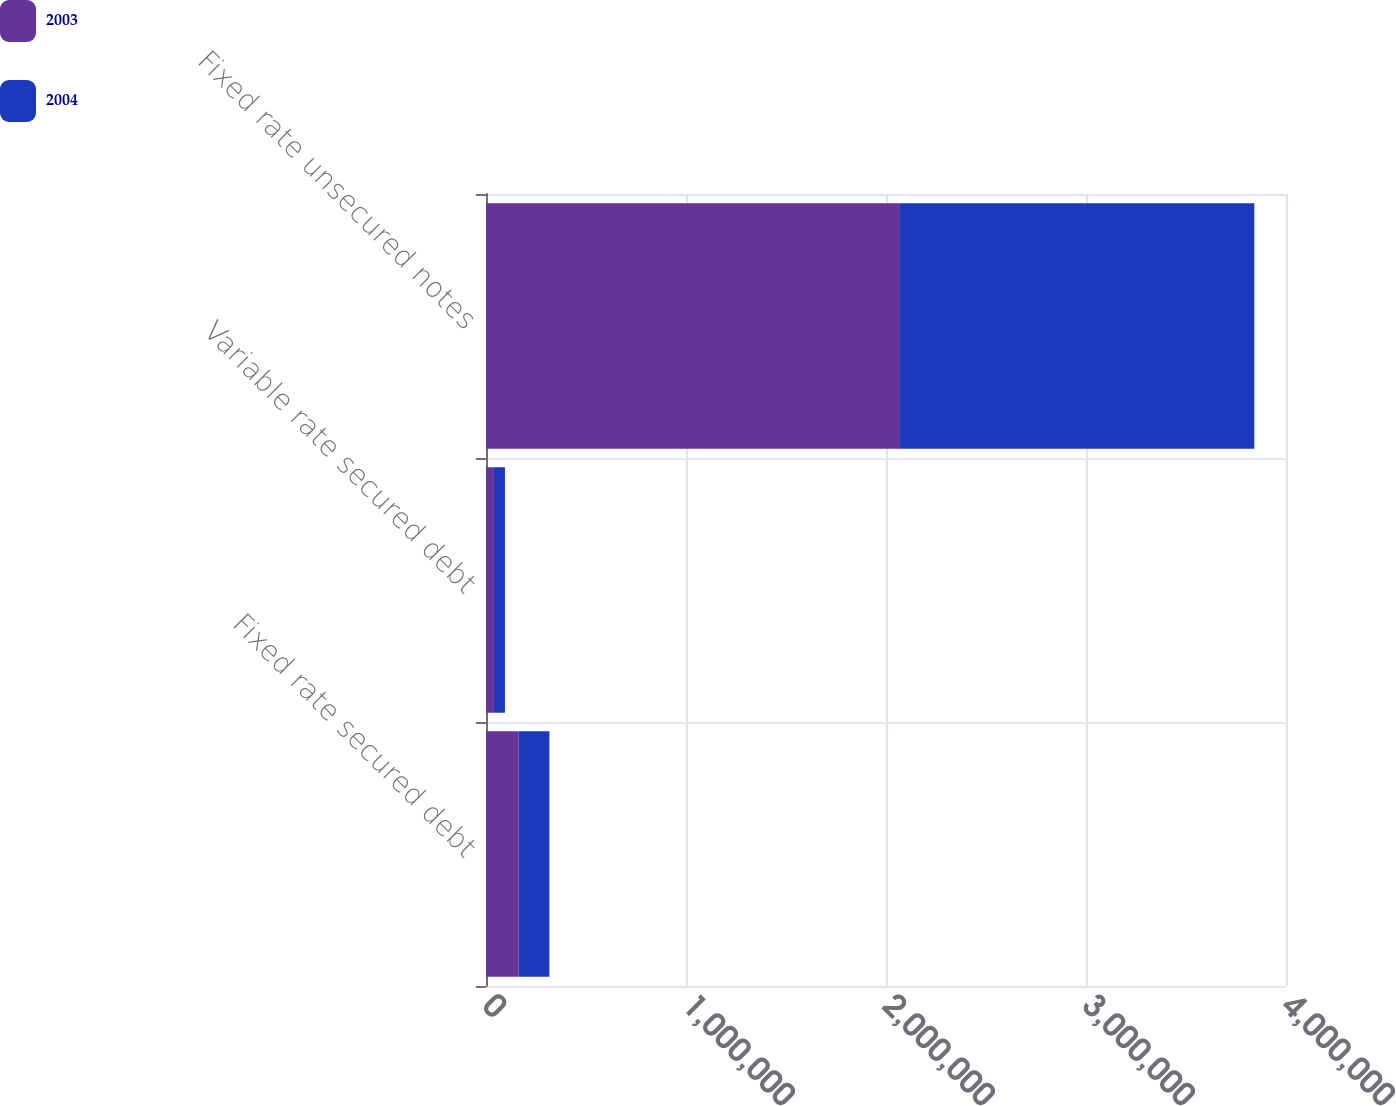Convert chart. <chart><loc_0><loc_0><loc_500><loc_500><stacked_bar_chart><ecel><fcel>Fixed rate secured debt<fcel>Variable rate secured debt<fcel>Fixed rate unsecured notes<nl><fcel>2003<fcel>163607<fcel>39474<fcel>2.06562e+06<nl><fcel>2004<fcel>153460<fcel>55189<fcel>1.77589e+06<nl></chart> 